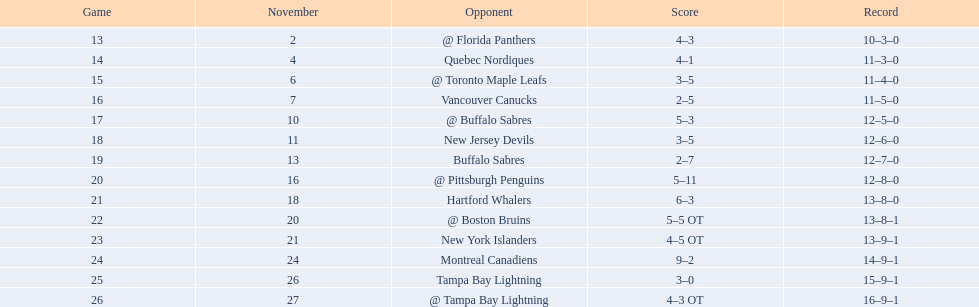Who did the philadelphia flyers play in game 17? @ Buffalo Sabres. What was the score of the november 10th game against the buffalo sabres? 5–3. Which team in the atlantic division had less points than the philadelphia flyers? Tampa Bay Lightning. 